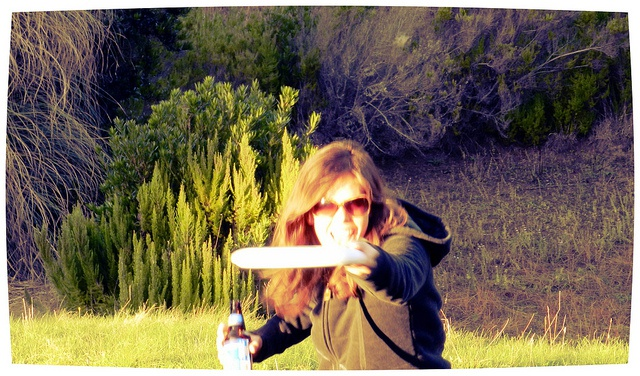Describe the objects in this image and their specific colors. I can see people in white, tan, black, and brown tones, frisbee in white, tan, and khaki tones, and bottle in white, brown, and tan tones in this image. 